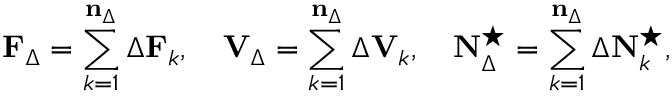<formula> <loc_0><loc_0><loc_500><loc_500>F _ { \Delta } = \sum _ { k = 1 } ^ { n _ { \Delta } } \Delta F _ { k } , \quad V _ { \Delta } = \sum _ { k = 1 } ^ { n _ { \Delta } } \Delta V _ { k } , \quad N _ { \Delta } ^ { ^ { * } } = \sum _ { k = 1 } ^ { n _ { \Delta } } \Delta N _ { k } ^ { ^ { * } } ,</formula> 